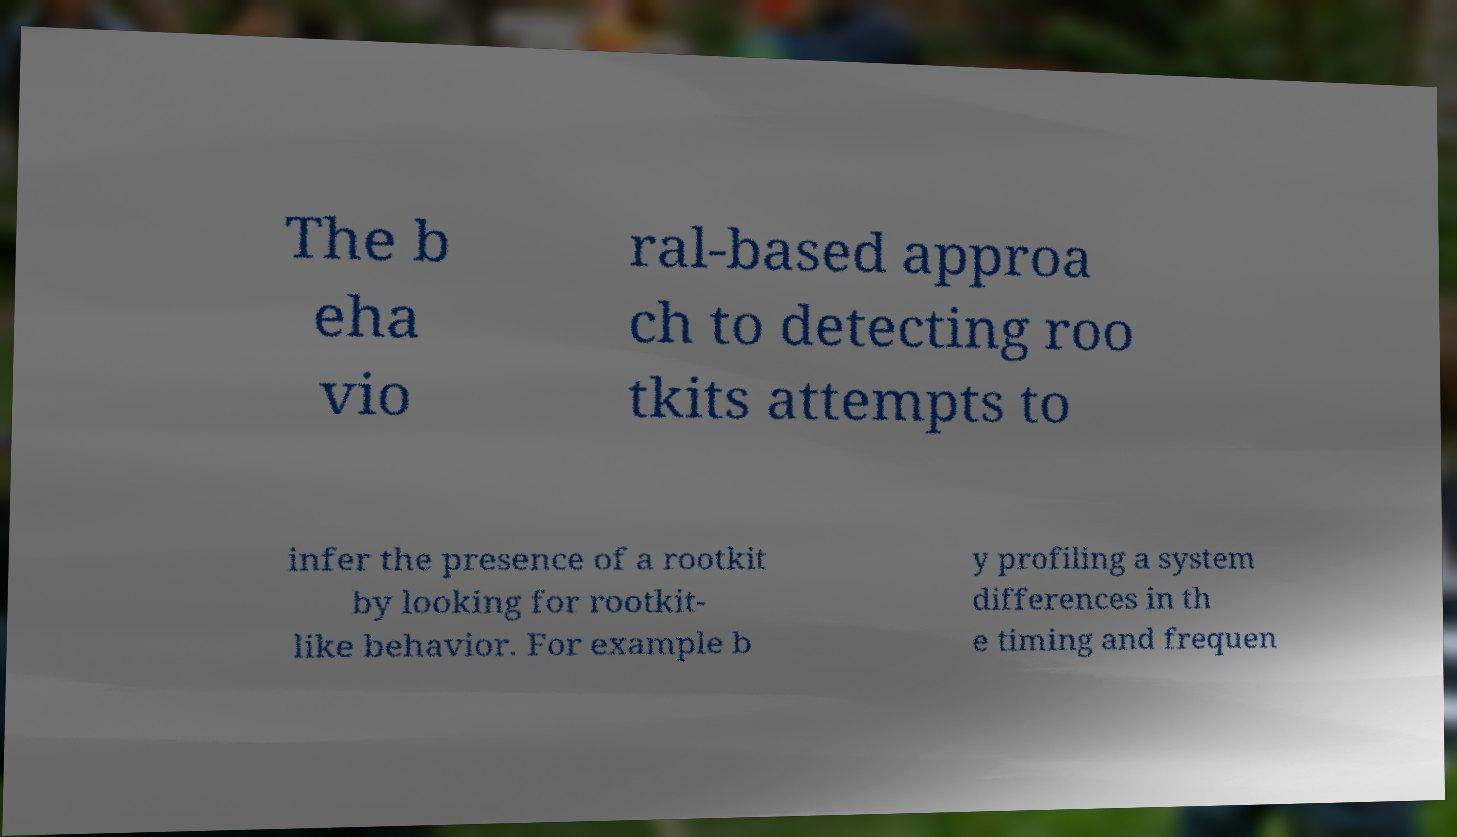Please read and relay the text visible in this image. What does it say? The b eha vio ral-based approa ch to detecting roo tkits attempts to infer the presence of a rootkit by looking for rootkit- like behavior. For example b y profiling a system differences in th e timing and frequen 